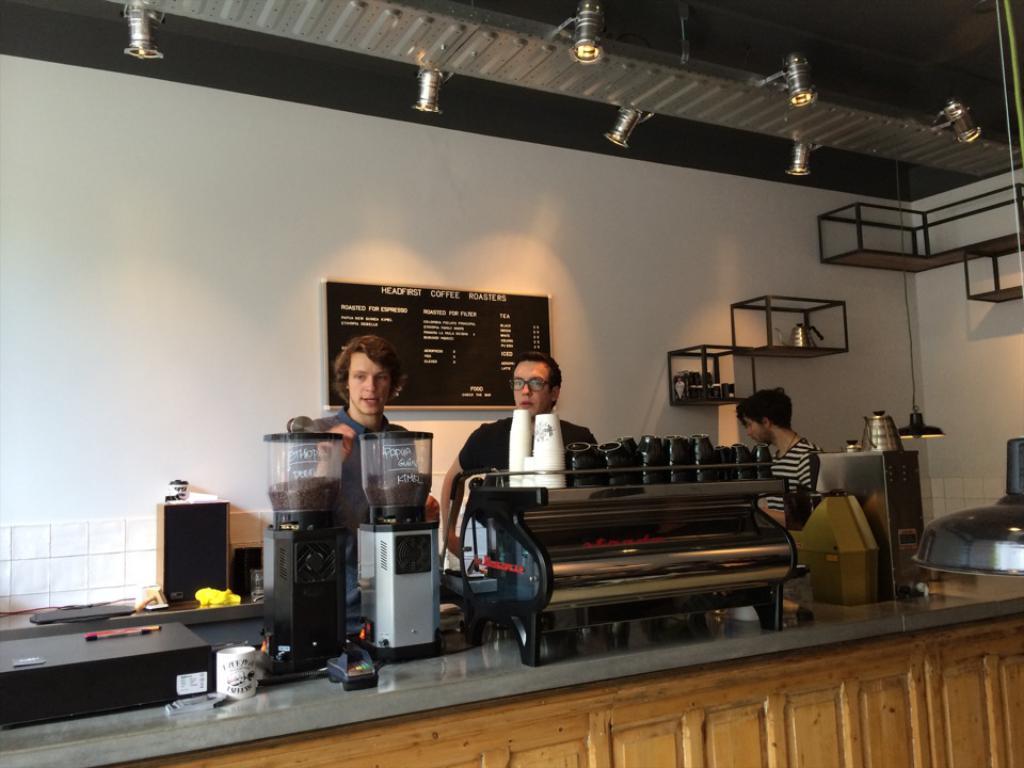What is the name of this coffee shop?
Your answer should be very brief. Headfirst coffee roasters. Do they offer coffee roasted for espresso?
Provide a short and direct response. Yes. 